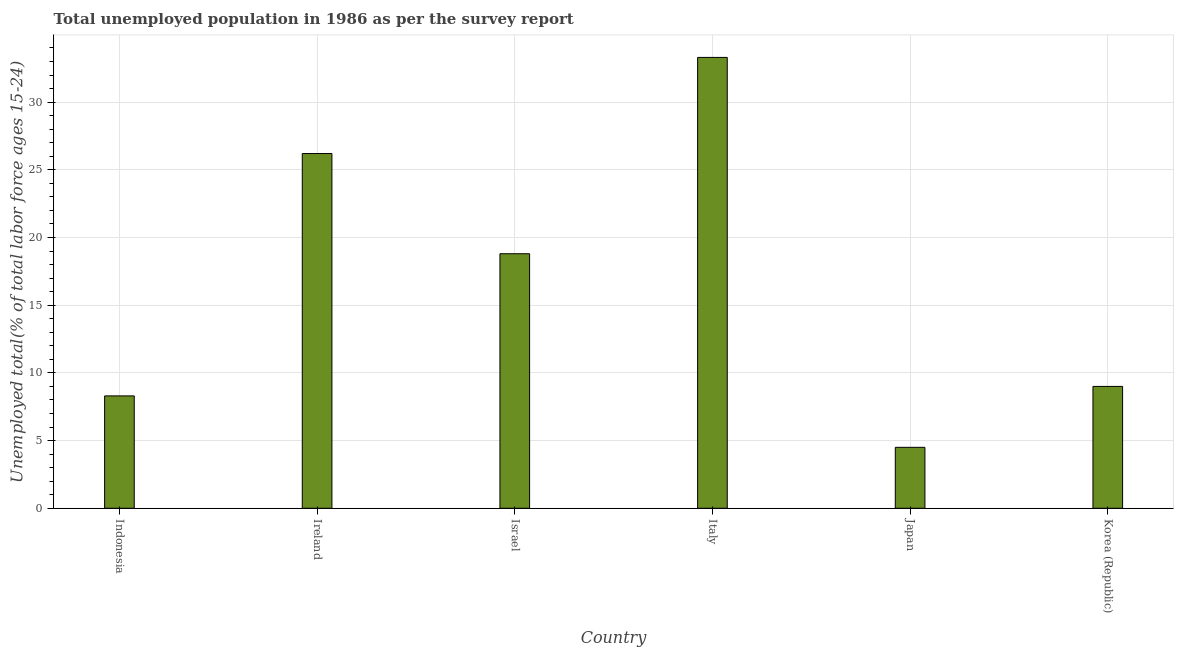Does the graph contain any zero values?
Provide a short and direct response. No. Does the graph contain grids?
Your answer should be very brief. Yes. What is the title of the graph?
Give a very brief answer. Total unemployed population in 1986 as per the survey report. What is the label or title of the X-axis?
Provide a succinct answer. Country. What is the label or title of the Y-axis?
Offer a very short reply. Unemployed total(% of total labor force ages 15-24). What is the unemployed youth in Indonesia?
Your response must be concise. 8.3. Across all countries, what is the maximum unemployed youth?
Provide a short and direct response. 33.3. In which country was the unemployed youth maximum?
Offer a very short reply. Italy. What is the sum of the unemployed youth?
Your response must be concise. 100.1. What is the difference between the unemployed youth in Indonesia and Ireland?
Keep it short and to the point. -17.9. What is the average unemployed youth per country?
Your answer should be very brief. 16.68. What is the median unemployed youth?
Offer a very short reply. 13.9. What is the difference between the highest and the second highest unemployed youth?
Ensure brevity in your answer.  7.1. What is the difference between the highest and the lowest unemployed youth?
Offer a very short reply. 28.8. Are all the bars in the graph horizontal?
Offer a terse response. No. How many countries are there in the graph?
Keep it short and to the point. 6. Are the values on the major ticks of Y-axis written in scientific E-notation?
Your answer should be compact. No. What is the Unemployed total(% of total labor force ages 15-24) in Indonesia?
Your answer should be very brief. 8.3. What is the Unemployed total(% of total labor force ages 15-24) of Ireland?
Provide a succinct answer. 26.2. What is the Unemployed total(% of total labor force ages 15-24) in Israel?
Ensure brevity in your answer.  18.8. What is the Unemployed total(% of total labor force ages 15-24) of Italy?
Your response must be concise. 33.3. What is the Unemployed total(% of total labor force ages 15-24) in Korea (Republic)?
Ensure brevity in your answer.  9. What is the difference between the Unemployed total(% of total labor force ages 15-24) in Indonesia and Ireland?
Offer a terse response. -17.9. What is the difference between the Unemployed total(% of total labor force ages 15-24) in Indonesia and Italy?
Give a very brief answer. -25. What is the difference between the Unemployed total(% of total labor force ages 15-24) in Indonesia and Japan?
Offer a very short reply. 3.8. What is the difference between the Unemployed total(% of total labor force ages 15-24) in Indonesia and Korea (Republic)?
Keep it short and to the point. -0.7. What is the difference between the Unemployed total(% of total labor force ages 15-24) in Ireland and Israel?
Provide a succinct answer. 7.4. What is the difference between the Unemployed total(% of total labor force ages 15-24) in Ireland and Italy?
Your response must be concise. -7.1. What is the difference between the Unemployed total(% of total labor force ages 15-24) in Ireland and Japan?
Offer a terse response. 21.7. What is the difference between the Unemployed total(% of total labor force ages 15-24) in Ireland and Korea (Republic)?
Offer a terse response. 17.2. What is the difference between the Unemployed total(% of total labor force ages 15-24) in Italy and Japan?
Your answer should be very brief. 28.8. What is the difference between the Unemployed total(% of total labor force ages 15-24) in Italy and Korea (Republic)?
Keep it short and to the point. 24.3. What is the ratio of the Unemployed total(% of total labor force ages 15-24) in Indonesia to that in Ireland?
Offer a very short reply. 0.32. What is the ratio of the Unemployed total(% of total labor force ages 15-24) in Indonesia to that in Israel?
Give a very brief answer. 0.44. What is the ratio of the Unemployed total(% of total labor force ages 15-24) in Indonesia to that in Italy?
Offer a very short reply. 0.25. What is the ratio of the Unemployed total(% of total labor force ages 15-24) in Indonesia to that in Japan?
Offer a terse response. 1.84. What is the ratio of the Unemployed total(% of total labor force ages 15-24) in Indonesia to that in Korea (Republic)?
Give a very brief answer. 0.92. What is the ratio of the Unemployed total(% of total labor force ages 15-24) in Ireland to that in Israel?
Provide a succinct answer. 1.39. What is the ratio of the Unemployed total(% of total labor force ages 15-24) in Ireland to that in Italy?
Provide a succinct answer. 0.79. What is the ratio of the Unemployed total(% of total labor force ages 15-24) in Ireland to that in Japan?
Keep it short and to the point. 5.82. What is the ratio of the Unemployed total(% of total labor force ages 15-24) in Ireland to that in Korea (Republic)?
Offer a terse response. 2.91. What is the ratio of the Unemployed total(% of total labor force ages 15-24) in Israel to that in Italy?
Your answer should be very brief. 0.56. What is the ratio of the Unemployed total(% of total labor force ages 15-24) in Israel to that in Japan?
Make the answer very short. 4.18. What is the ratio of the Unemployed total(% of total labor force ages 15-24) in Israel to that in Korea (Republic)?
Offer a very short reply. 2.09. What is the ratio of the Unemployed total(% of total labor force ages 15-24) in Italy to that in Japan?
Your answer should be compact. 7.4. What is the ratio of the Unemployed total(% of total labor force ages 15-24) in Italy to that in Korea (Republic)?
Your answer should be compact. 3.7. What is the ratio of the Unemployed total(% of total labor force ages 15-24) in Japan to that in Korea (Republic)?
Offer a terse response. 0.5. 